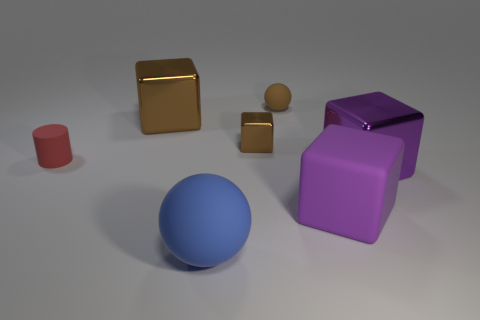Add 2 rubber things. How many objects exist? 9 Subtract all purple metal cubes. How many cubes are left? 3 Subtract all brown cubes. How many cubes are left? 2 Subtract 1 balls. How many balls are left? 1 Subtract all yellow balls. Subtract all gray cylinders. How many balls are left? 2 Subtract all yellow cubes. How many blue cylinders are left? 0 Subtract all small green rubber objects. Subtract all brown balls. How many objects are left? 6 Add 6 small balls. How many small balls are left? 7 Add 6 small red rubber objects. How many small red rubber objects exist? 7 Subtract 0 gray cylinders. How many objects are left? 7 